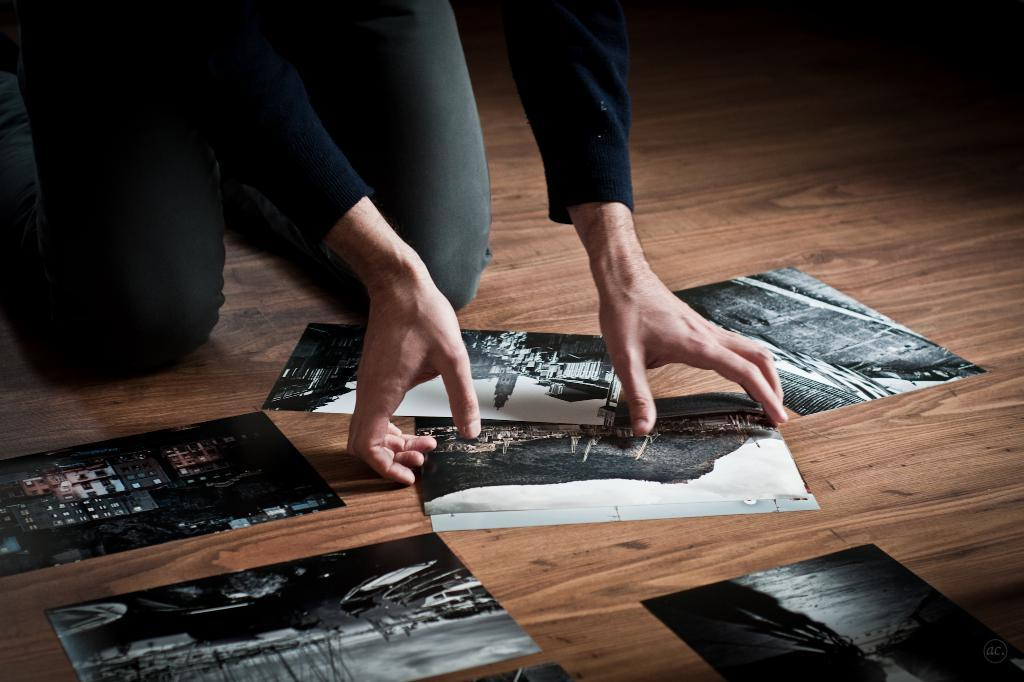Where is the person located in the image? The person is sitting in the top left side of the image. What can be seen on the floor in the image? There are photos on the floor. What type of surface is visible in the background of the image? There is a floor visible in the background of the image. How many wounds can be seen on the person in the image? There is no indication of any wounds on the person in the image. What type of print is visible on the person's clothing in the image? There is no visible print on the person's clothing in the image. 